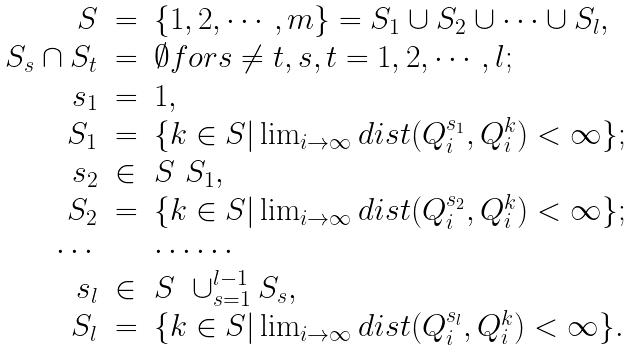Convert formula to latex. <formula><loc_0><loc_0><loc_500><loc_500>\begin{array} [ ] { r c l } S & = & \{ 1 , 2 , \cdots , m \} = S _ { 1 } \cup S _ { 2 } \cup \cdots \cup S _ { l } , \\ S _ { s } \cap S _ { t } & = & \emptyset f o r s \ne t , s , t = 1 , 2 , \cdots , l ; \\ s _ { 1 } & = & 1 , \\ S _ { 1 } & = & \{ k \in S | \lim _ { i \to \infty } d i s t ( Q _ { i } ^ { s _ { 1 } } , Q _ { i } ^ { k } ) < \infty \} ; \\ s _ { 2 } & \in & S \ S _ { 1 } , \\ S _ { 2 } & = & \{ k \in S | \lim _ { i \to \infty } d i s t ( Q _ { i } ^ { s _ { 2 } } , Q _ { i } ^ { k } ) < \infty \} ; \\ \cdots & & \cdots \cdots \\ s _ { l } & \in & S \ \cup _ { s = 1 } ^ { l - 1 } S _ { s } , \\ S _ { l } & = & \{ k \in S | \lim _ { i \to \infty } d i s t ( Q _ { i } ^ { s _ { l } } , Q _ { i } ^ { k } ) < \infty \} . \\ \end{array}</formula> 